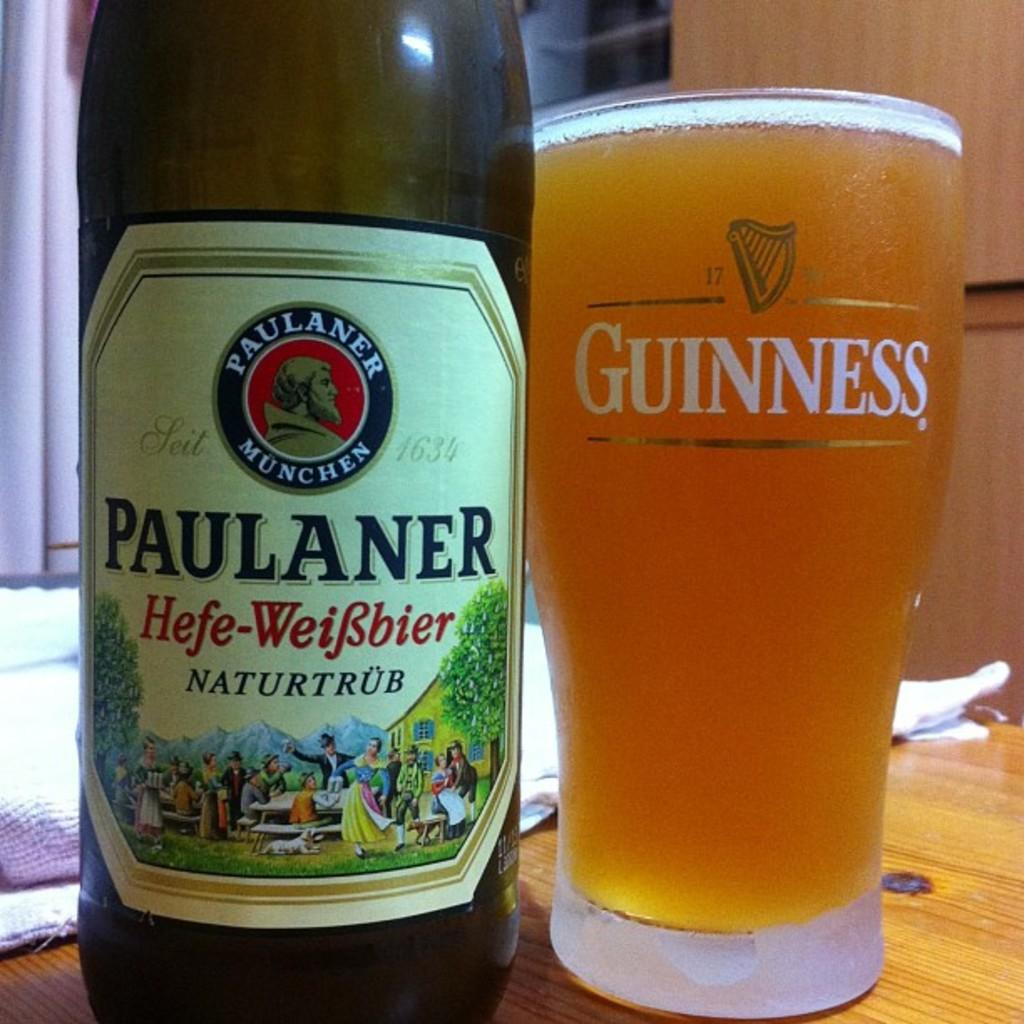<image>
Relay a brief, clear account of the picture shown. Paulaner Munchen beer has been poured into a Guinness glass 